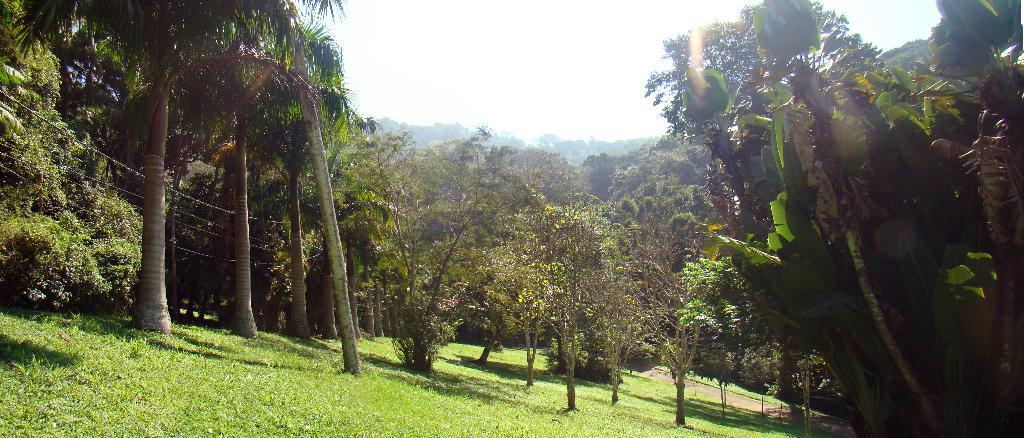Where was the picture taken? The picture was clicked outside. What can be seen in the foreground of the image? There is green grass in the foreground of the image. What is located in the center of the image? There are trees in the center of the image. What is visible in the background of the image? There is a sky visible in the background of the image. What type of pie is being served in the image? There is no pie present in the image; it is a picture taken outside with green grass, trees, and a sky visible. 